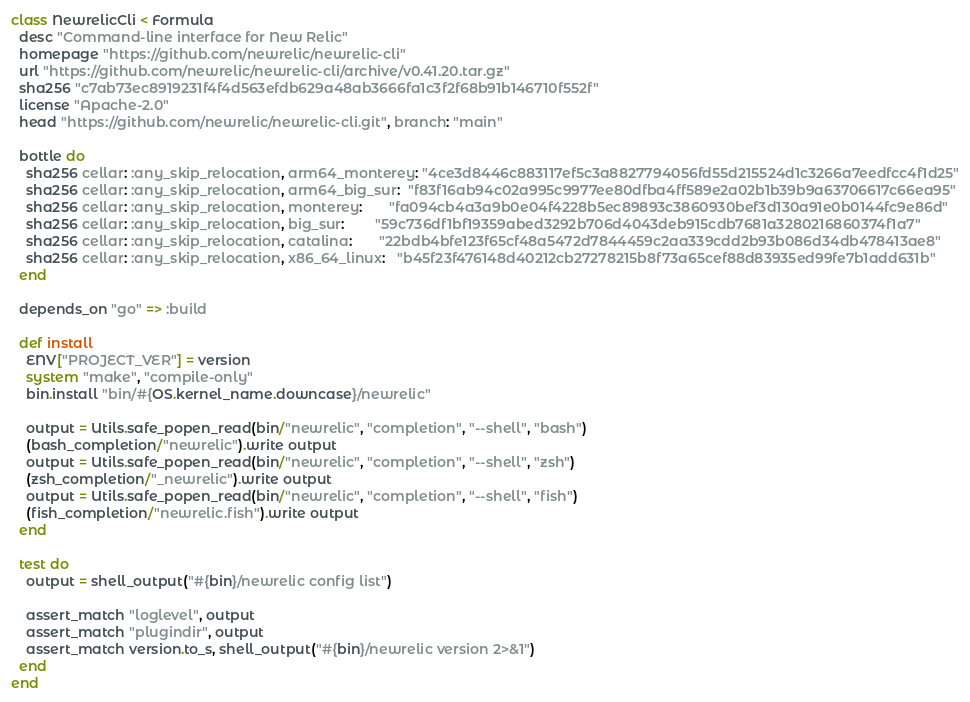<code> <loc_0><loc_0><loc_500><loc_500><_Ruby_>class NewrelicCli < Formula
  desc "Command-line interface for New Relic"
  homepage "https://github.com/newrelic/newrelic-cli"
  url "https://github.com/newrelic/newrelic-cli/archive/v0.41.20.tar.gz"
  sha256 "c7ab73ec8919231f4f4d563efdb629a48ab3666fa1c3f2f68b91b146710f552f"
  license "Apache-2.0"
  head "https://github.com/newrelic/newrelic-cli.git", branch: "main"

  bottle do
    sha256 cellar: :any_skip_relocation, arm64_monterey: "4ce3d8446c883117ef5c3a8827794056fd55d215524d1c3266a7eedfcc4f1d25"
    sha256 cellar: :any_skip_relocation, arm64_big_sur:  "f83f16ab94c02a995c9977ee80dfba4ff589e2a02b1b39b9a63706617c66ea95"
    sha256 cellar: :any_skip_relocation, monterey:       "fa094cb4a3a9b0e04f4228b5ec89893c3860930bef3d130a91e0b0144fc9e86d"
    sha256 cellar: :any_skip_relocation, big_sur:        "59c736df1bf19359abed3292b706d4043deb915cdb7681a3280216860374f1a7"
    sha256 cellar: :any_skip_relocation, catalina:       "22bdb4bfe123f65cf48a5472d7844459c2aa339cdd2b93b086d34db478413ae8"
    sha256 cellar: :any_skip_relocation, x86_64_linux:   "b45f23f476148d40212cb27278215b8f73a65cef88d83935ed99fe7b1add631b"
  end

  depends_on "go" => :build

  def install
    ENV["PROJECT_VER"] = version
    system "make", "compile-only"
    bin.install "bin/#{OS.kernel_name.downcase}/newrelic"

    output = Utils.safe_popen_read(bin/"newrelic", "completion", "--shell", "bash")
    (bash_completion/"newrelic").write output
    output = Utils.safe_popen_read(bin/"newrelic", "completion", "--shell", "zsh")
    (zsh_completion/"_newrelic").write output
    output = Utils.safe_popen_read(bin/"newrelic", "completion", "--shell", "fish")
    (fish_completion/"newrelic.fish").write output
  end

  test do
    output = shell_output("#{bin}/newrelic config list")

    assert_match "loglevel", output
    assert_match "plugindir", output
    assert_match version.to_s, shell_output("#{bin}/newrelic version 2>&1")
  end
end
</code> 